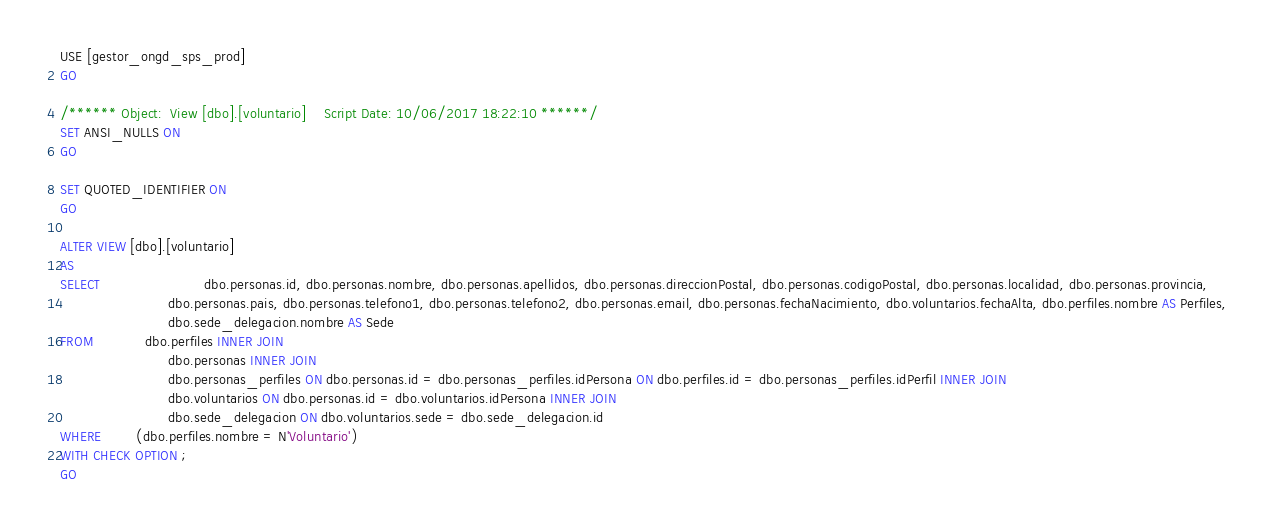Convert code to text. <code><loc_0><loc_0><loc_500><loc_500><_SQL_>USE [gestor_ongd_sps_prod]
GO

/****** Object:  View [dbo].[voluntario]    Script Date: 10/06/2017 18:22:10 ******/
SET ANSI_NULLS ON
GO

SET QUOTED_IDENTIFIER ON
GO

ALTER VIEW [dbo].[voluntario]
AS
SELECT						dbo.personas.id, dbo.personas.nombre, dbo.personas.apellidos, dbo.personas.direccionPostal, dbo.personas.codigoPostal, dbo.personas.localidad, dbo.personas.provincia, 
                         dbo.personas.pais, dbo.personas.telefono1, dbo.personas.telefono2, dbo.personas.email, dbo.personas.fechaNacimiento, dbo.voluntarios.fechaAlta, dbo.perfiles.nombre AS Perfiles, 
                         dbo.sede_delegacion.nombre AS Sede
FROM            dbo.perfiles INNER JOIN
                         dbo.personas INNER JOIN
                         dbo.personas_perfiles ON dbo.personas.id = dbo.personas_perfiles.idPersona ON dbo.perfiles.id = dbo.personas_perfiles.idPerfil INNER JOIN
                         dbo.voluntarios ON dbo.personas.id = dbo.voluntarios.idPersona INNER JOIN
                         dbo.sede_delegacion ON dbo.voluntarios.sede = dbo.sede_delegacion.id
WHERE        (dbo.perfiles.nombre = N'Voluntario')
WITH CHECK OPTION ;  
GO



</code> 